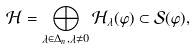<formula> <loc_0><loc_0><loc_500><loc_500>\mathcal { H } = \bigoplus _ { \lambda \in \Delta _ { n } , \lambda \not = 0 } \mathcal { H } _ { \lambda } ( \varphi ) \subset { \mathcal { S } } ( \varphi ) ,</formula> 